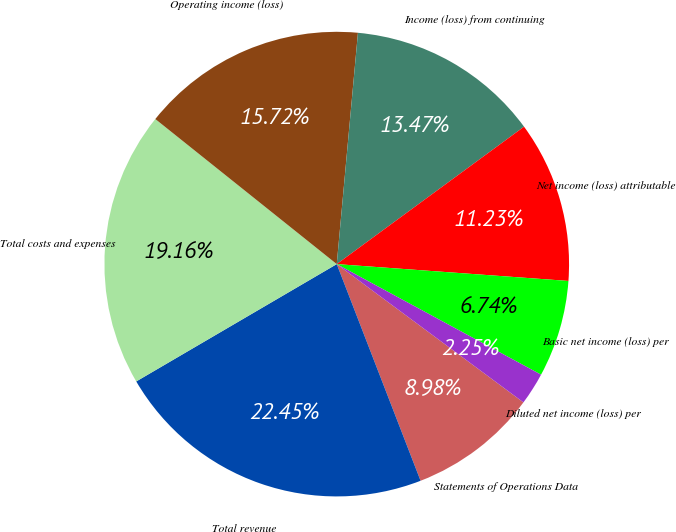<chart> <loc_0><loc_0><loc_500><loc_500><pie_chart><fcel>Statements of Operations Data<fcel>Total revenue<fcel>Total costs and expenses<fcel>Operating income (loss)<fcel>Income (loss) from continuing<fcel>Net income (loss) attributable<fcel>Basic net income (loss) per<fcel>Diluted net income (loss) per<nl><fcel>8.98%<fcel>22.45%<fcel>19.16%<fcel>15.72%<fcel>13.47%<fcel>11.23%<fcel>6.74%<fcel>2.25%<nl></chart> 